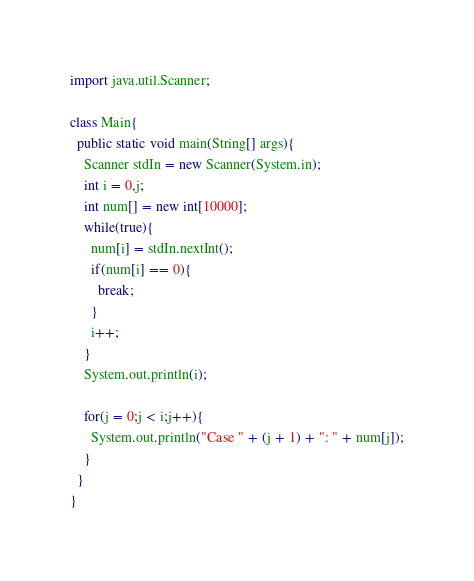<code> <loc_0><loc_0><loc_500><loc_500><_Java_>import java.util.Scanner;

class Main{
  public static void main(String[] args){
    Scanner stdIn = new Scanner(System.in);
    int i = 0,j;
    int num[] = new int[10000];
    while(true){
      num[i] = stdIn.nextInt();
      if(num[i] == 0){
        break;
      }
      i++;
    }
    System.out.println(i);

    for(j = 0;j < i;j++){
      System.out.println("Case " + (j + 1) + ": " + num[j]);
    }
  }
}</code> 